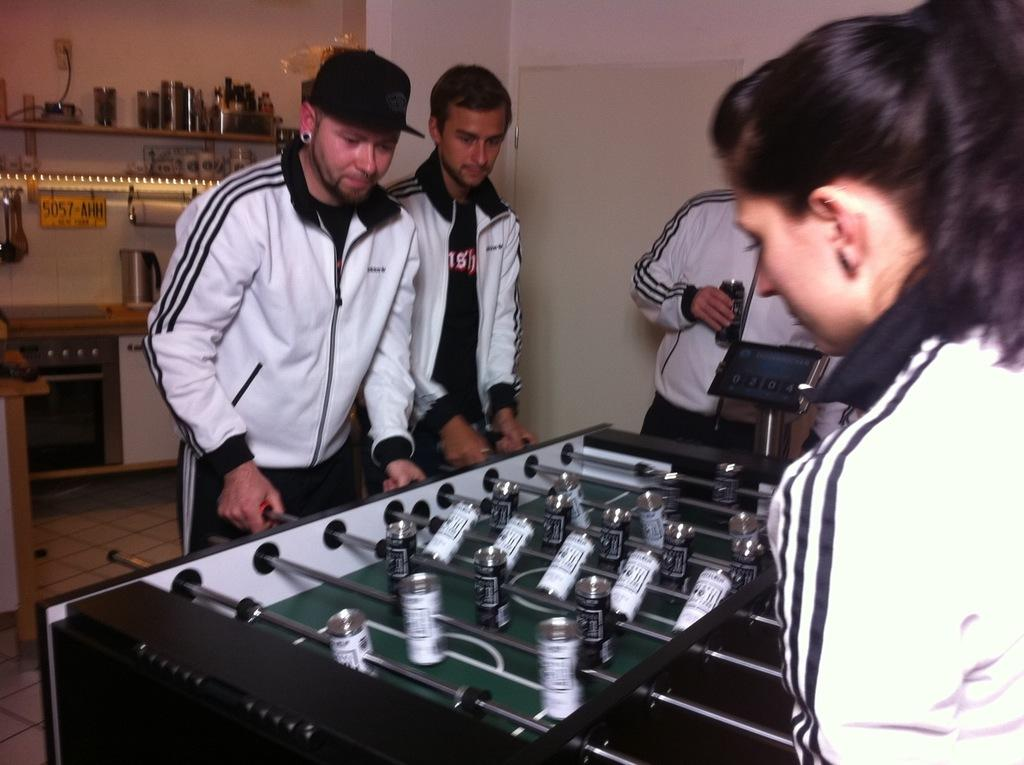How many people are in the image? There is a group of people in the image. What are some of the people doing in the image? Some people are playing table football. What can be seen in the background of the image? There are lights visible in the background, as well as an oven and other unspecified objects. What type of market is visible in the image? There is no market present in the image. What kind of machine is being used by the people playing table football? The people playing table football are not using a machine; they are playing a game that involves manually moving the players on the table. 